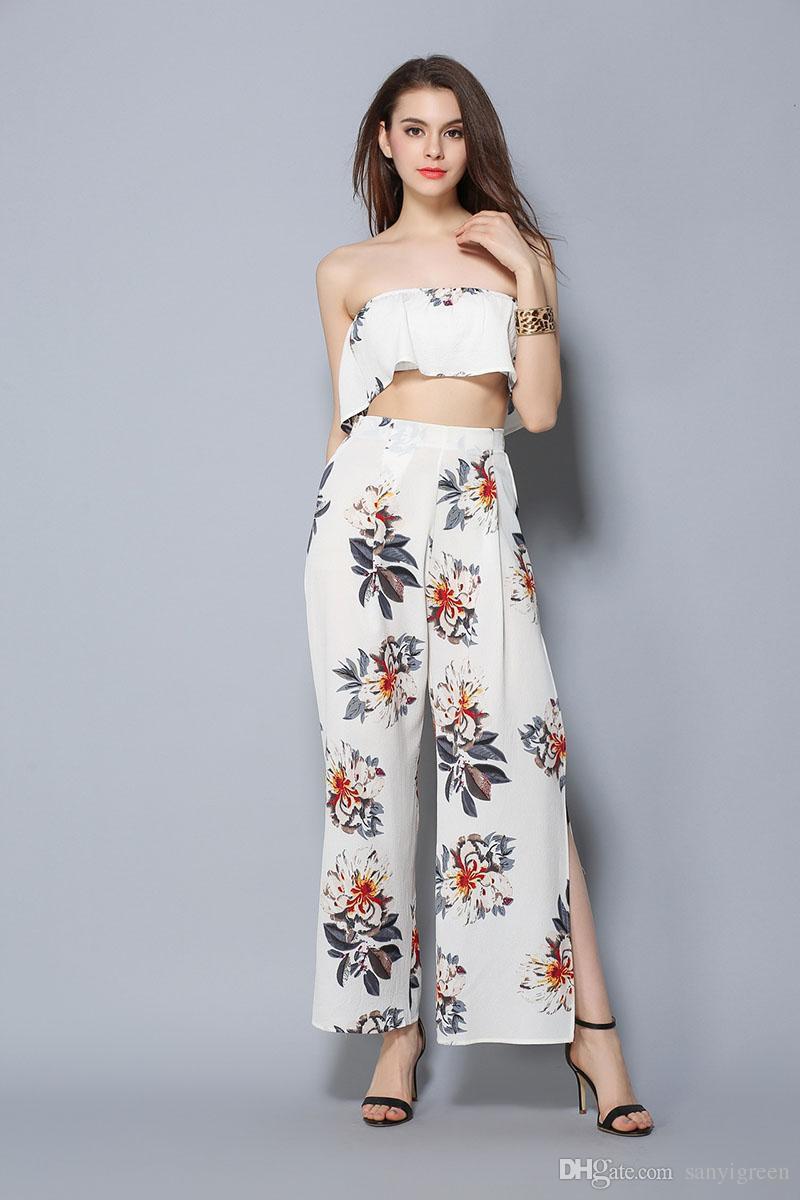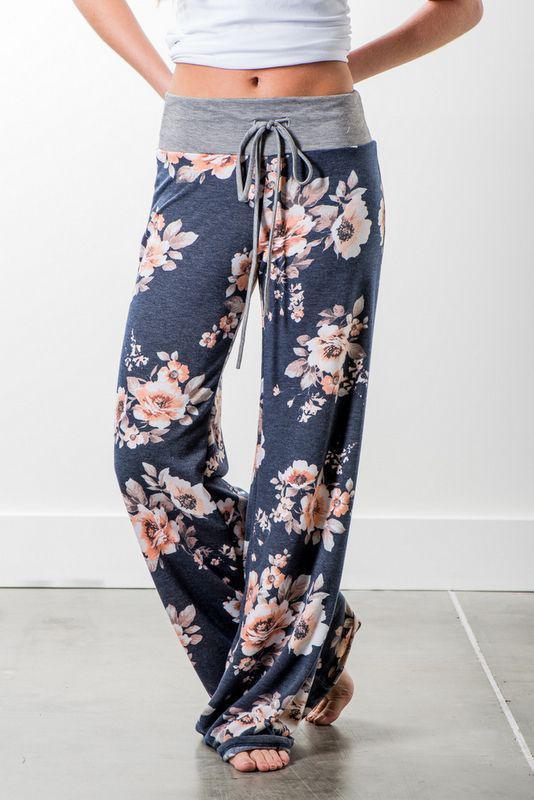The first image is the image on the left, the second image is the image on the right. Analyze the images presented: Is the assertion "A person is wearing the clothing on the right." valid? Answer yes or no. Yes. 